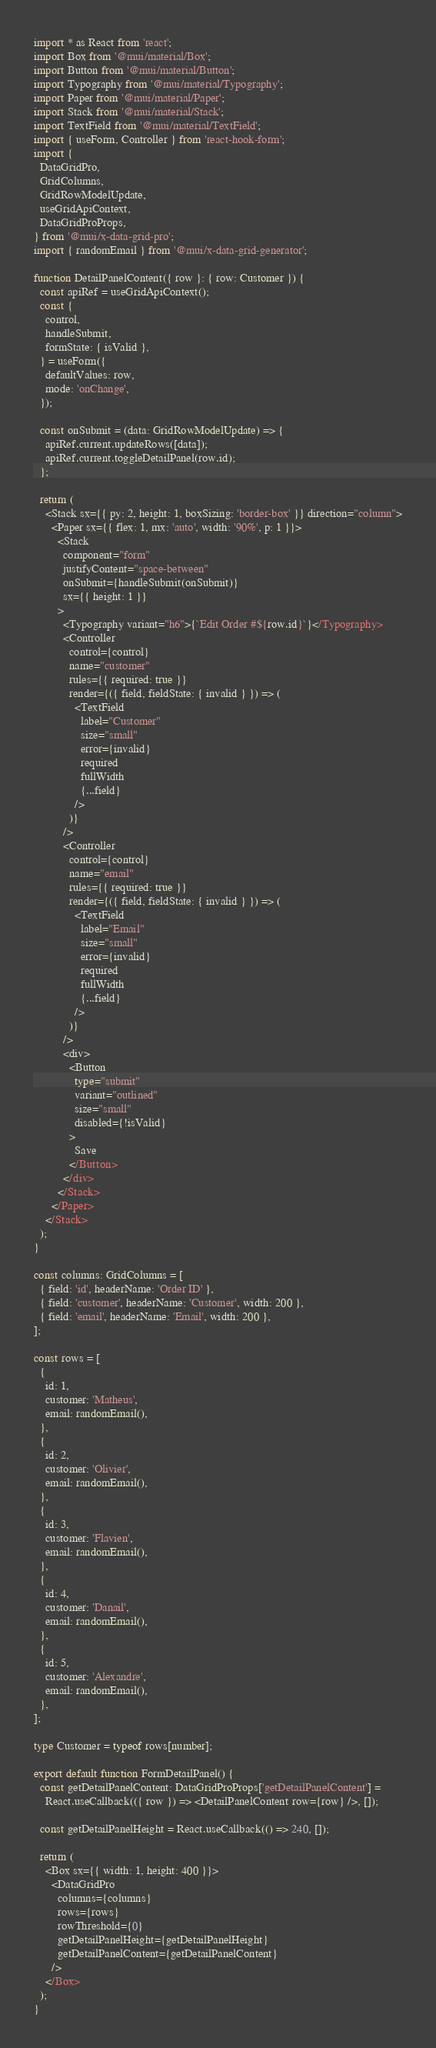Convert code to text. <code><loc_0><loc_0><loc_500><loc_500><_TypeScript_>import * as React from 'react';
import Box from '@mui/material/Box';
import Button from '@mui/material/Button';
import Typography from '@mui/material/Typography';
import Paper from '@mui/material/Paper';
import Stack from '@mui/material/Stack';
import TextField from '@mui/material/TextField';
import { useForm, Controller } from 'react-hook-form';
import {
  DataGridPro,
  GridColumns,
  GridRowModelUpdate,
  useGridApiContext,
  DataGridProProps,
} from '@mui/x-data-grid-pro';
import { randomEmail } from '@mui/x-data-grid-generator';

function DetailPanelContent({ row }: { row: Customer }) {
  const apiRef = useGridApiContext();
  const {
    control,
    handleSubmit,
    formState: { isValid },
  } = useForm({
    defaultValues: row,
    mode: 'onChange',
  });

  const onSubmit = (data: GridRowModelUpdate) => {
    apiRef.current.updateRows([data]);
    apiRef.current.toggleDetailPanel(row.id);
  };

  return (
    <Stack sx={{ py: 2, height: 1, boxSizing: 'border-box' }} direction="column">
      <Paper sx={{ flex: 1, mx: 'auto', width: '90%', p: 1 }}>
        <Stack
          component="form"
          justifyContent="space-between"
          onSubmit={handleSubmit(onSubmit)}
          sx={{ height: 1 }}
        >
          <Typography variant="h6">{`Edit Order #${row.id}`}</Typography>
          <Controller
            control={control}
            name="customer"
            rules={{ required: true }}
            render={({ field, fieldState: { invalid } }) => (
              <TextField
                label="Customer"
                size="small"
                error={invalid}
                required
                fullWidth
                {...field}
              />
            )}
          />
          <Controller
            control={control}
            name="email"
            rules={{ required: true }}
            render={({ field, fieldState: { invalid } }) => (
              <TextField
                label="Email"
                size="small"
                error={invalid}
                required
                fullWidth
                {...field}
              />
            )}
          />
          <div>
            <Button
              type="submit"
              variant="outlined"
              size="small"
              disabled={!isValid}
            >
              Save
            </Button>
          </div>
        </Stack>
      </Paper>
    </Stack>
  );
}

const columns: GridColumns = [
  { field: 'id', headerName: 'Order ID' },
  { field: 'customer', headerName: 'Customer', width: 200 },
  { field: 'email', headerName: 'Email', width: 200 },
];

const rows = [
  {
    id: 1,
    customer: 'Matheus',
    email: randomEmail(),
  },
  {
    id: 2,
    customer: 'Olivier',
    email: randomEmail(),
  },
  {
    id: 3,
    customer: 'Flavien',
    email: randomEmail(),
  },
  {
    id: 4,
    customer: 'Danail',
    email: randomEmail(),
  },
  {
    id: 5,
    customer: 'Alexandre',
    email: randomEmail(),
  },
];

type Customer = typeof rows[number];

export default function FormDetailPanel() {
  const getDetailPanelContent: DataGridProProps['getDetailPanelContent'] =
    React.useCallback(({ row }) => <DetailPanelContent row={row} />, []);

  const getDetailPanelHeight = React.useCallback(() => 240, []);

  return (
    <Box sx={{ width: 1, height: 400 }}>
      <DataGridPro
        columns={columns}
        rows={rows}
        rowThreshold={0}
        getDetailPanelHeight={getDetailPanelHeight}
        getDetailPanelContent={getDetailPanelContent}
      />
    </Box>
  );
}
</code> 